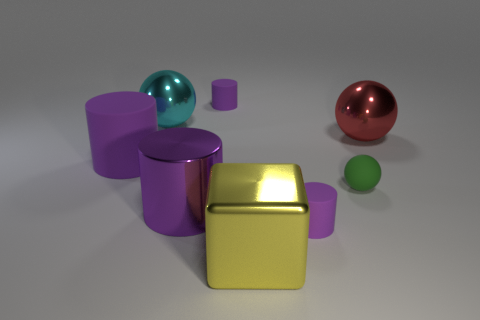How many purple cylinders must be subtracted to get 1 purple cylinders? 3 Subtract all metallic balls. How many balls are left? 1 Subtract all green balls. How many balls are left? 2 Add 1 large metallic cylinders. How many objects exist? 9 Subtract all blocks. How many objects are left? 7 Subtract 1 balls. How many balls are left? 2 Subtract 0 cyan cylinders. How many objects are left? 8 Subtract all brown cylinders. Subtract all yellow spheres. How many cylinders are left? 4 Subtract all big red metal spheres. Subtract all tiny purple balls. How many objects are left? 7 Add 1 purple rubber cylinders. How many purple rubber cylinders are left? 4 